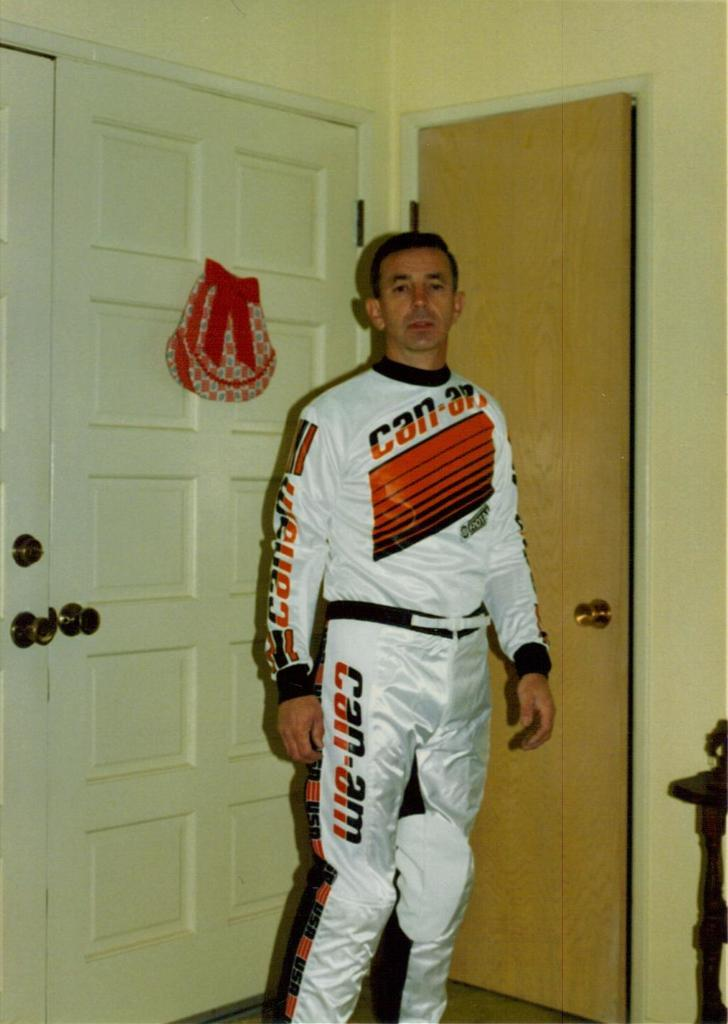Provide a one-sentence caption for the provided image. A man wears a set of white coveralls that say can-am on the chest, leg, and arm. 